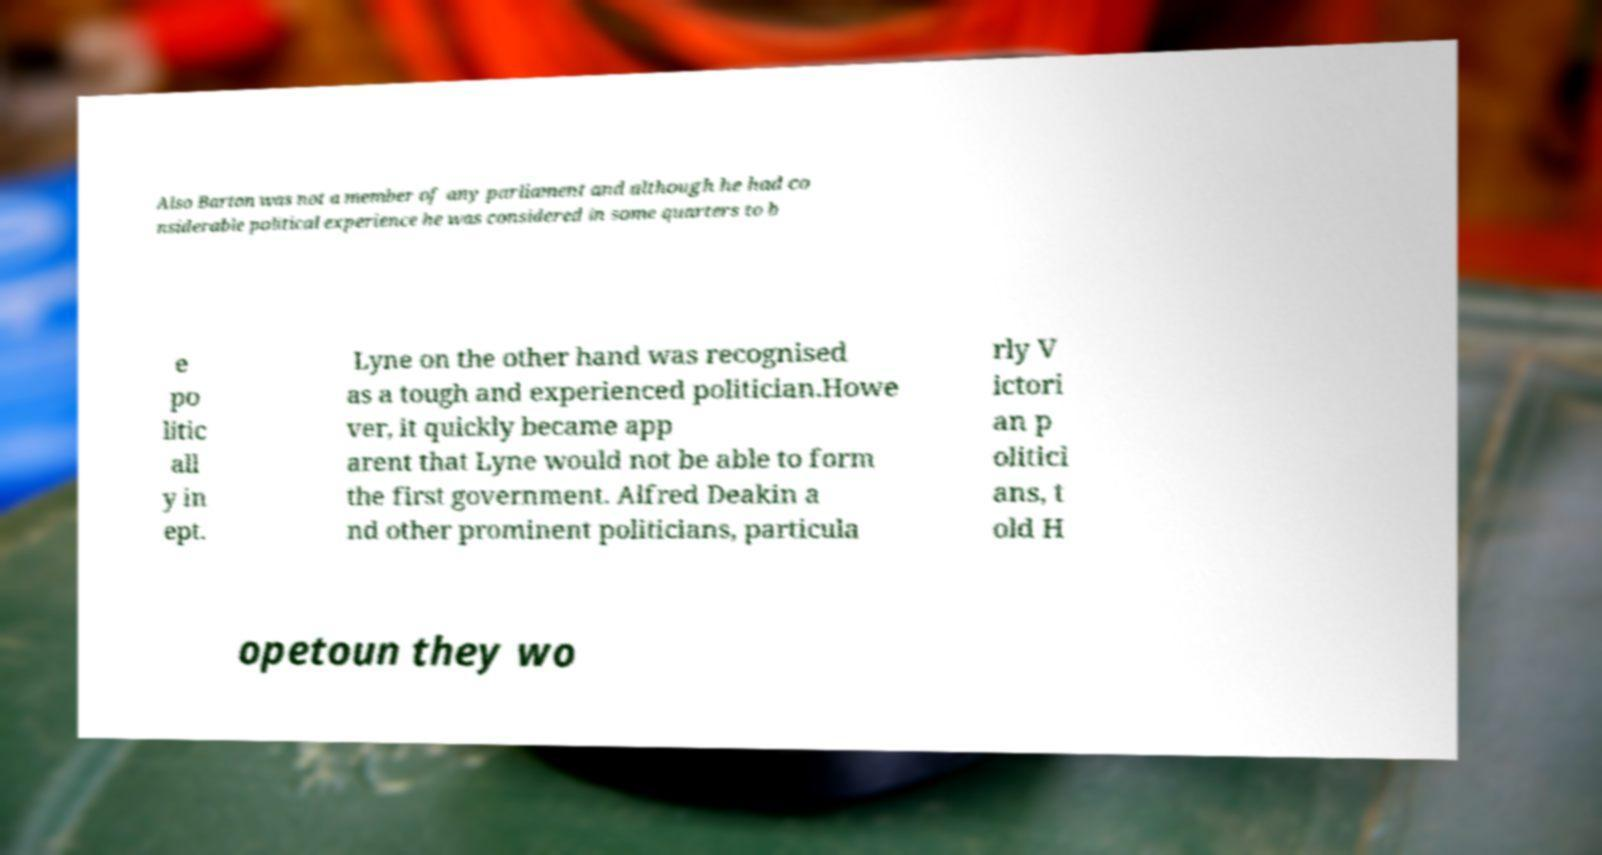Please read and relay the text visible in this image. What does it say? Also Barton was not a member of any parliament and although he had co nsiderable political experience he was considered in some quarters to b e po litic all y in ept. Lyne on the other hand was recognised as a tough and experienced politician.Howe ver, it quickly became app arent that Lyne would not be able to form the first government. Alfred Deakin a nd other prominent politicians, particula rly V ictori an p olitici ans, t old H opetoun they wo 